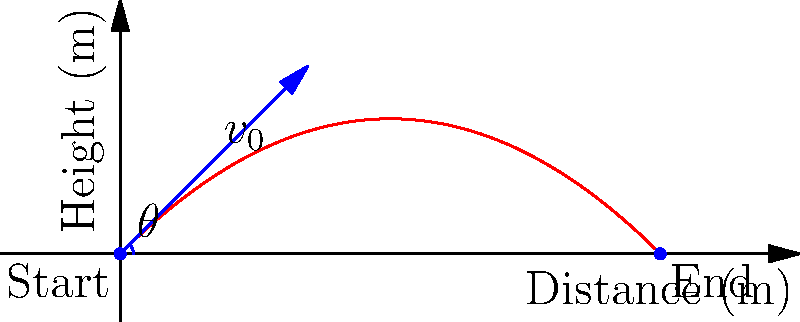Given a dart thrown with an initial velocity of 20 m/s at a 45-degree angle, calculate the maximum height reached by the dart. Assume standard gravity (g = 9.81 m/s²) and neglect air resistance. To find the maximum height reached by the dart, we can follow these steps:

1. Identify the relevant equations:
   - Vertical motion: $y = v_0 \sin(\theta) t - \frac{1}{2}gt^2$
   - Time to reach maximum height: $t_{max} = \frac{v_0 \sin(\theta)}{g}$

2. Calculate the time to reach maximum height:
   $t_{max} = \frac{20 \sin(45°)}{9.81} = \frac{20 \cdot 0.707}{9.81} \approx 1.44$ seconds

3. Use the vertical motion equation to find the maximum height:
   $y_{max} = v_0 \sin(\theta) t_{max} - \frac{1}{2}g(t_{max})^2$

4. Substitute the values:
   $y_{max} = 20 \sin(45°) \cdot 1.44 - \frac{1}{2} \cdot 9.81 \cdot (1.44)^2$

5. Calculate:
   $y_{max} = 20 \cdot 0.707 \cdot 1.44 - 4.905 \cdot 2.0736$
   $y_{max} = 20.36 - 10.17 \approx 10.19$ meters

Therefore, the maximum height reached by the dart is approximately 10.19 meters.
Answer: 10.19 m 